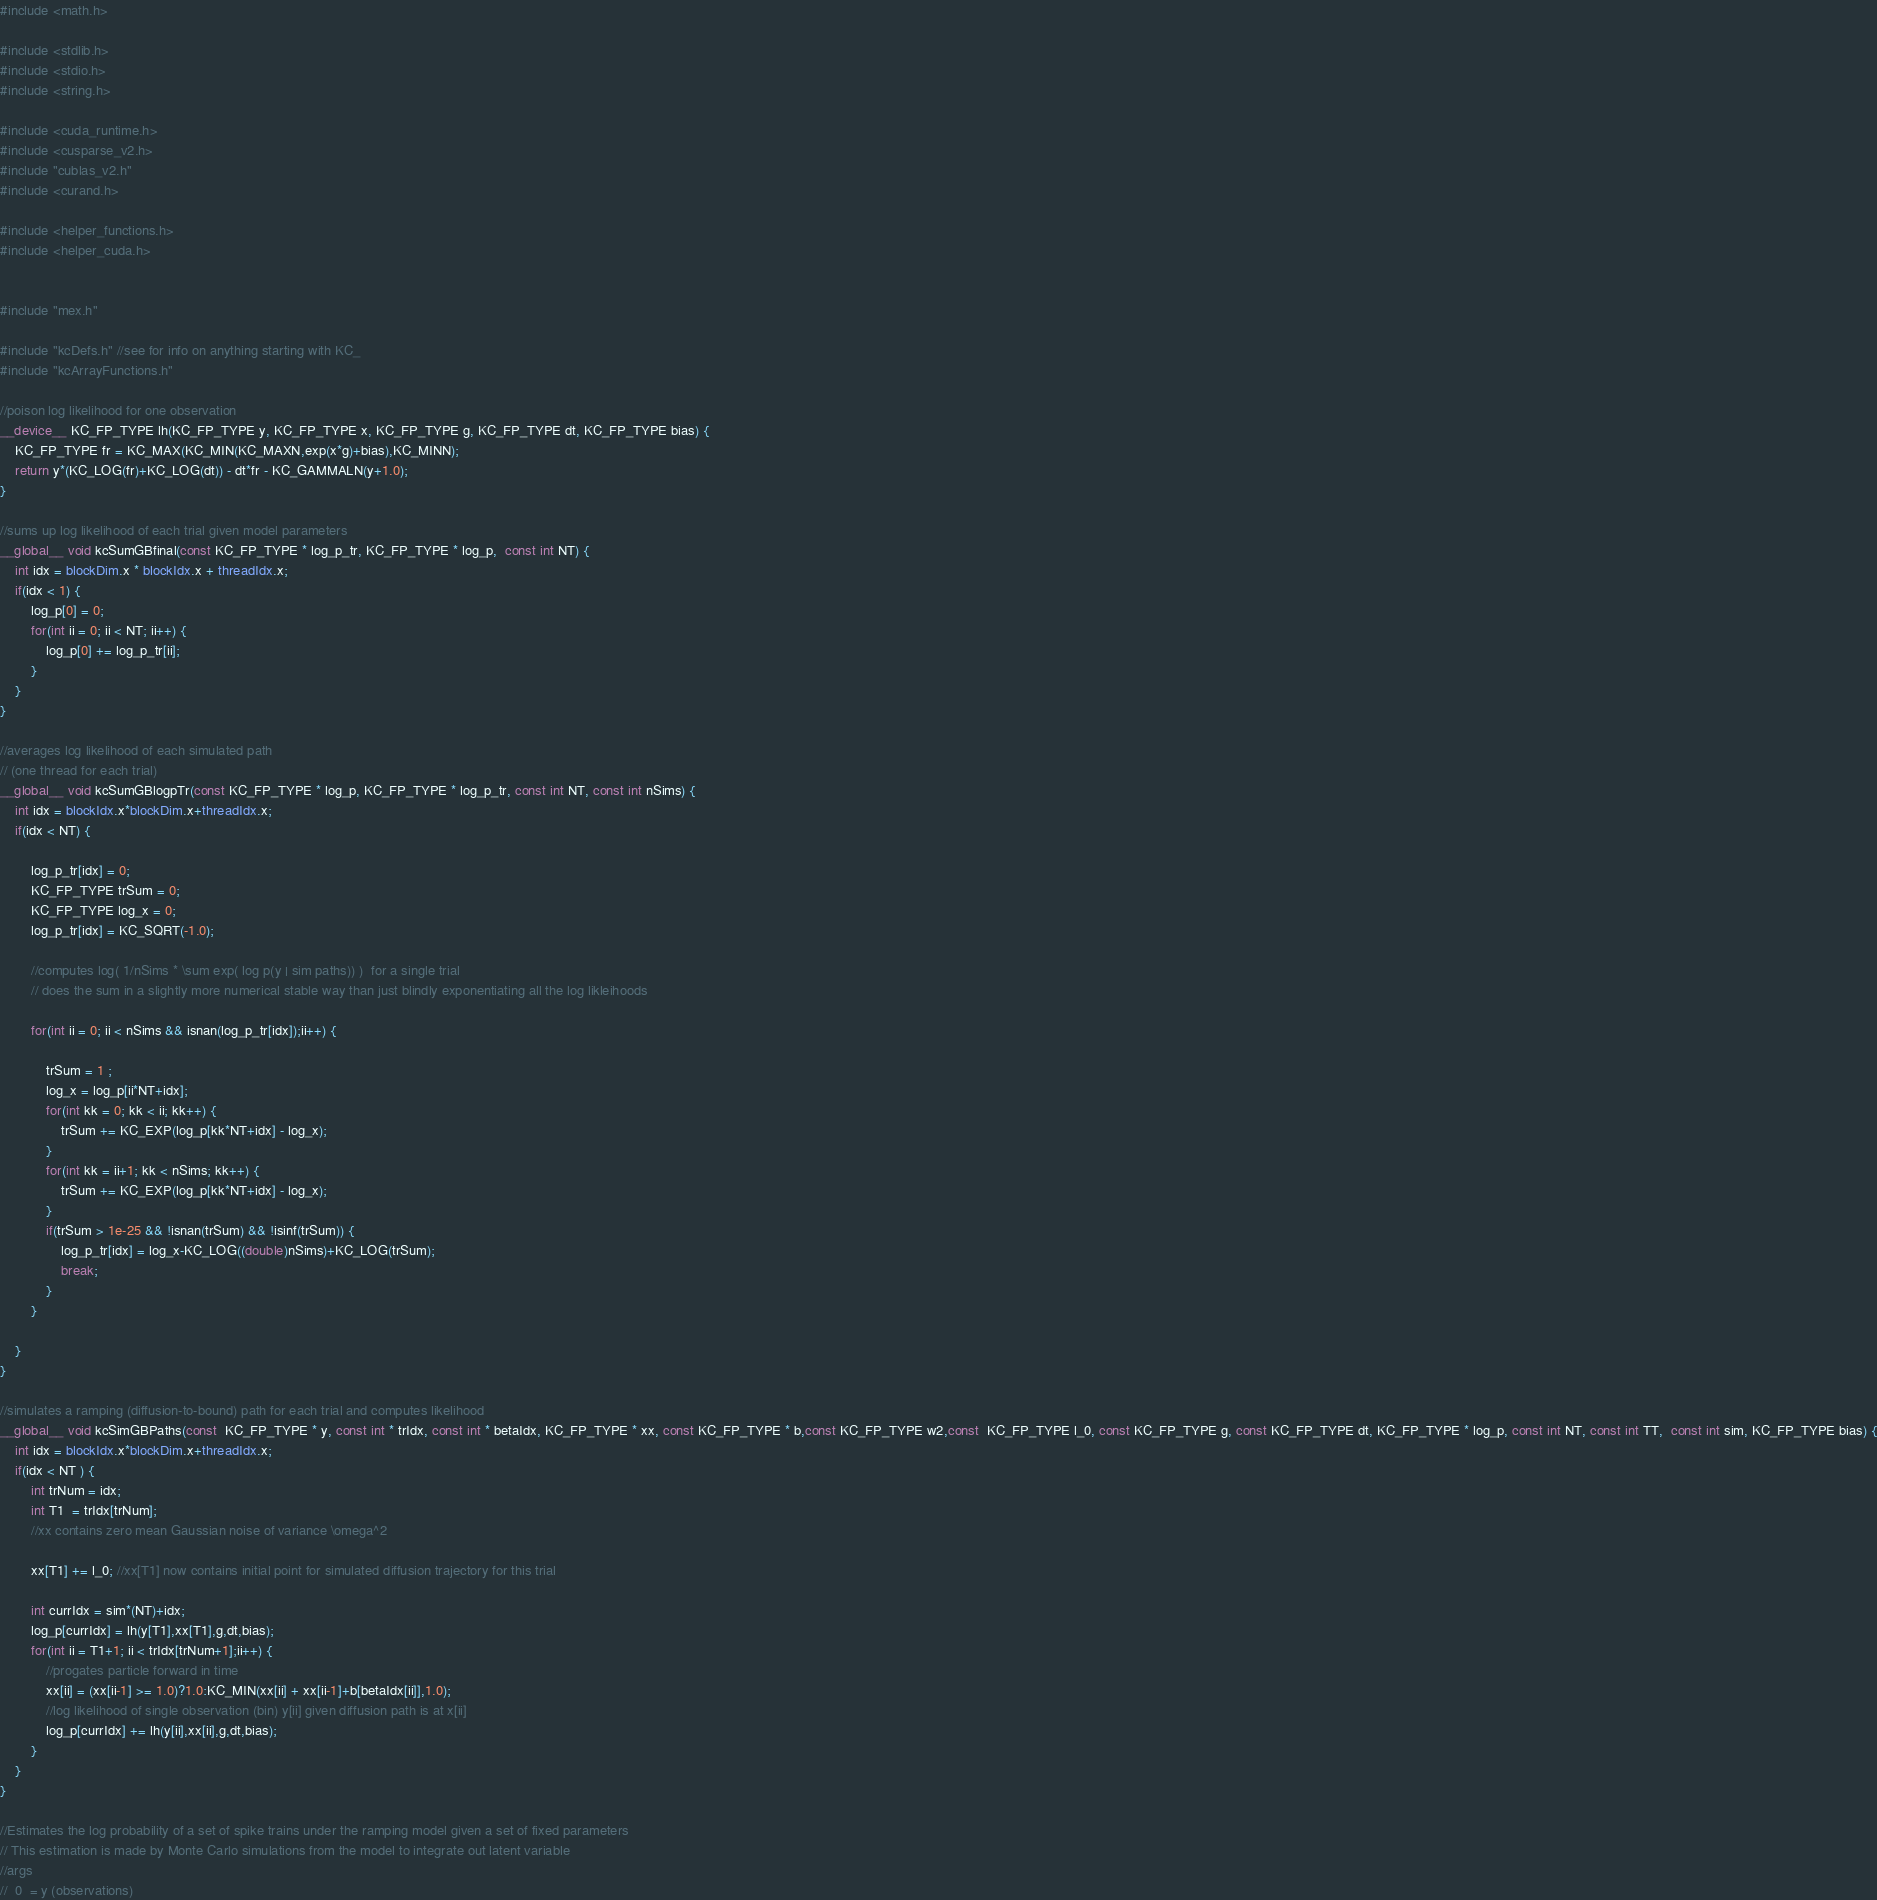<code> <loc_0><loc_0><loc_500><loc_500><_Cuda_>#include <math.h>

#include <stdlib.h>
#include <stdio.h>
#include <string.h>

#include <cuda_runtime.h>
#include <cusparse_v2.h>
#include "cublas_v2.h"
#include <curand.h>

#include <helper_functions.h>
#include <helper_cuda.h>


#include "mex.h"

#include "kcDefs.h" //see for info on anything starting with KC_
#include "kcArrayFunctions.h"

//poison log likelihood for one observation
__device__ KC_FP_TYPE lh(KC_FP_TYPE y, KC_FP_TYPE x, KC_FP_TYPE g, KC_FP_TYPE dt, KC_FP_TYPE bias) {
    KC_FP_TYPE fr = KC_MAX(KC_MIN(KC_MAXN,exp(x*g)+bias),KC_MINN);
    return y*(KC_LOG(fr)+KC_LOG(dt)) - dt*fr - KC_GAMMALN(y+1.0);
}

//sums up log likelihood of each trial given model parameters
__global__ void kcSumGBfinal(const KC_FP_TYPE * log_p_tr, KC_FP_TYPE * log_p,  const int NT) {
    int idx = blockDim.x * blockIdx.x + threadIdx.x;
    if(idx < 1) {
        log_p[0] = 0;
        for(int ii = 0; ii < NT; ii++) {
            log_p[0] += log_p_tr[ii];
        }
    }
}

//averages log likelihood of each simulated path
// (one thread for each trial)
__global__ void kcSumGBlogpTr(const KC_FP_TYPE * log_p, KC_FP_TYPE * log_p_tr, const int NT, const int nSims) {
    int idx = blockIdx.x*blockDim.x+threadIdx.x;
    if(idx < NT) {
        
        log_p_tr[idx] = 0;
        KC_FP_TYPE trSum = 0;
        KC_FP_TYPE log_x = 0;
        log_p_tr[idx] = KC_SQRT(-1.0);
        
        //computes log( 1/nSims * \sum exp( log p(y | sim paths)) )  for a single trial
        // does the sum in a slightly more numerical stable way than just blindly exponentiating all the log likleihoods
        
        for(int ii = 0; ii < nSims && isnan(log_p_tr[idx]);ii++) {

            trSum = 1 ;
            log_x = log_p[ii*NT+idx];
            for(int kk = 0; kk < ii; kk++) {
                trSum += KC_EXP(log_p[kk*NT+idx] - log_x);
            }
            for(int kk = ii+1; kk < nSims; kk++) {
                trSum += KC_EXP(log_p[kk*NT+idx] - log_x);
            }
            if(trSum > 1e-25 && !isnan(trSum) && !isinf(trSum)) {
                log_p_tr[idx] = log_x-KC_LOG((double)nSims)+KC_LOG(trSum);
                break;
            }
        }
        
    }
}

//simulates a ramping (diffusion-to-bound) path for each trial and computes likelihood
__global__ void kcSimGBPaths(const  KC_FP_TYPE * y, const int * trIdx, const int * betaIdx, KC_FP_TYPE * xx, const KC_FP_TYPE * b,const KC_FP_TYPE w2,const  KC_FP_TYPE l_0, const KC_FP_TYPE g, const KC_FP_TYPE dt, KC_FP_TYPE * log_p, const int NT, const int TT,  const int sim, KC_FP_TYPE bias) {
    int idx = blockIdx.x*blockDim.x+threadIdx.x;
    if(idx < NT ) {
        int trNum = idx;
        int T1  = trIdx[trNum];
        //xx contains zero mean Gaussian noise of variance \omega^2
        
        xx[T1] += l_0; //xx[T1] now contains initial point for simulated diffusion trajectory for this trial
        
        int currIdx = sim*(NT)+idx;
        log_p[currIdx] = lh(y[T1],xx[T1],g,dt,bias);
        for(int ii = T1+1; ii < trIdx[trNum+1];ii++) {
            //progates particle forward in time
            xx[ii] = (xx[ii-1] >= 1.0)?1.0:KC_MIN(xx[ii] + xx[ii-1]+b[betaIdx[ii]],1.0);
            //log likelihood of single observation (bin) y[ii] given diffusion path is at x[ii]
            log_p[currIdx] += lh(y[ii],xx[ii],g,dt,bias);
        }
    }
}

//Estimates the log probability of a set of spike trains under the ramping model given a set of fixed parameters
// This estimation is made by Monte Carlo simulations from the model to integrate out latent variable
//args
//  0  = y (observations)</code> 